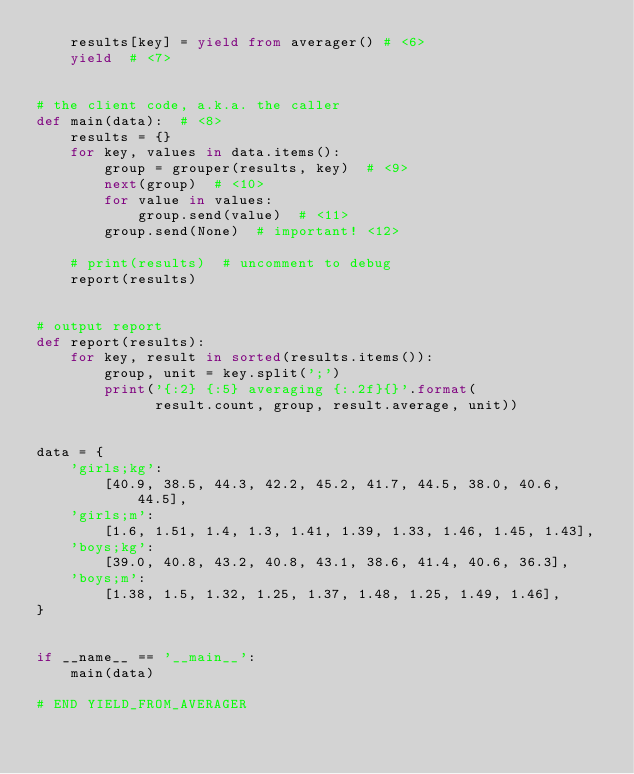<code> <loc_0><loc_0><loc_500><loc_500><_Python_>    results[key] = yield from averager() # <6>
    yield  # <7>


# the client code, a.k.a. the caller
def main(data):  # <8>
    results = {}
    for key, values in data.items():
        group = grouper(results, key)  # <9>
        next(group)  # <10>
        for value in values:
            group.send(value)  # <11>
        group.send(None)  # important! <12>

    # print(results)  # uncomment to debug
    report(results)


# output report
def report(results):
    for key, result in sorted(results.items()):
        group, unit = key.split(';')
        print('{:2} {:5} averaging {:.2f}{}'.format(
              result.count, group, result.average, unit))


data = {
    'girls;kg':
        [40.9, 38.5, 44.3, 42.2, 45.2, 41.7, 44.5, 38.0, 40.6, 44.5],
    'girls;m':
        [1.6, 1.51, 1.4, 1.3, 1.41, 1.39, 1.33, 1.46, 1.45, 1.43],
    'boys;kg':
        [39.0, 40.8, 43.2, 40.8, 43.1, 38.6, 41.4, 40.6, 36.3],
    'boys;m':
        [1.38, 1.5, 1.32, 1.25, 1.37, 1.48, 1.25, 1.49, 1.46],
}


if __name__ == '__main__':
    main(data)

# END YIELD_FROM_AVERAGER
</code> 